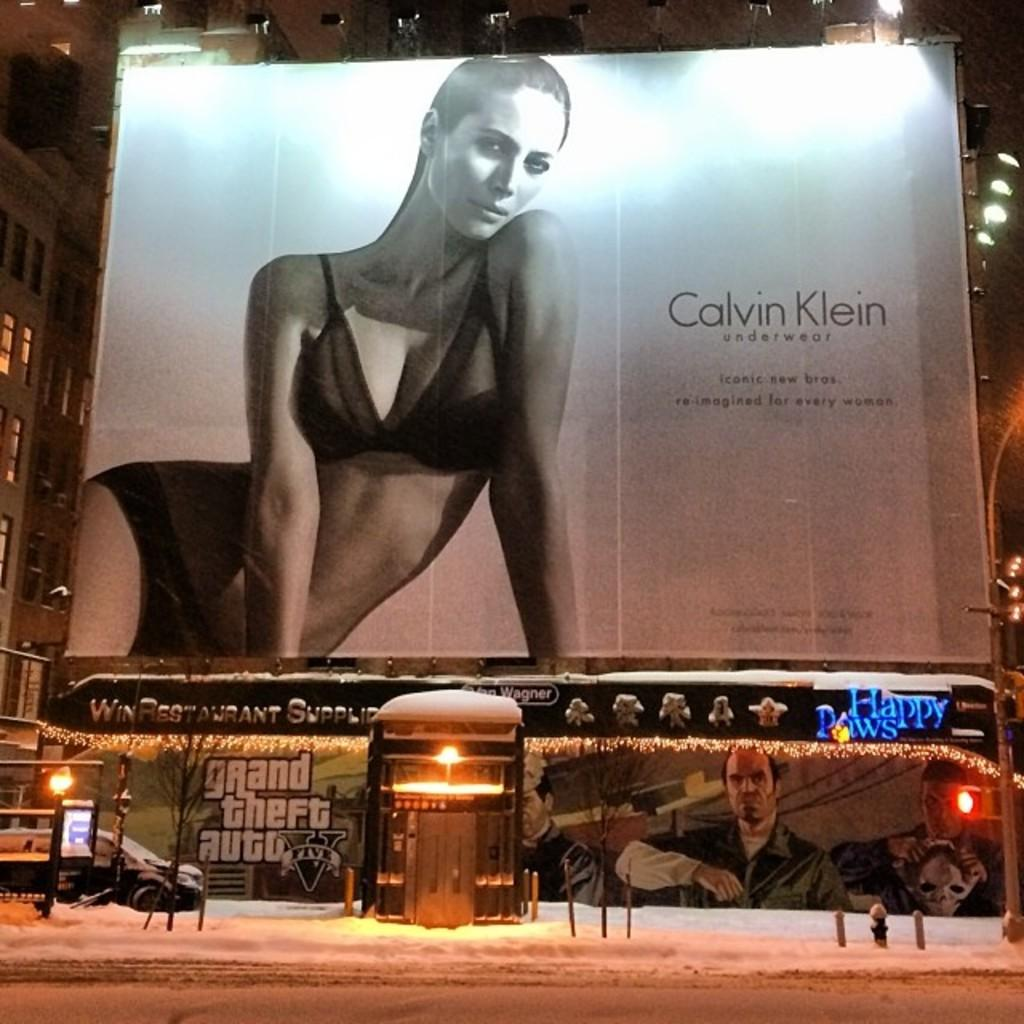<image>
Write a terse but informative summary of the picture. A Calvin Klein billboard advertisement where a model is promoting underwear. 